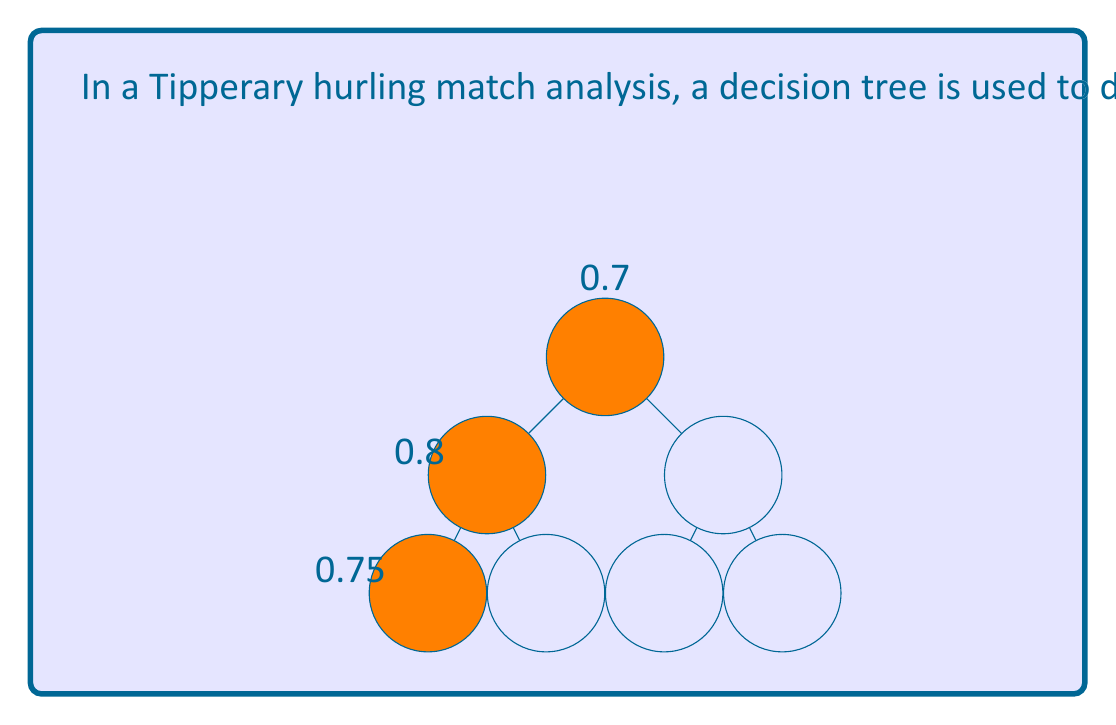Teach me how to tackle this problem. To solve this problem, we need to follow these steps:

1) In a decision tree, the probability of reaching the optimal outcome is the product of the probabilities of making the correct choice at each level.

2) We are given the probabilities for each level:
   - Level 1: $p_1 = 0.7$
   - Level 2: $p_2 = 0.8$
   - Level 3: $p_3 = 0.75$

3) The overall probability is the product of these individual probabilities:

   $$P(\text{optimal}) = p_1 \times p_2 \times p_3$$

4) Substituting the values:

   $$P(\text{optimal}) = 0.7 \times 0.8 \times 0.75$$

5) Calculating:

   $$P(\text{optimal}) = 0.42$$

Therefore, the probability of selecting the most effective formation using this decision tree is 0.42 or 42%.
Answer: 0.42 